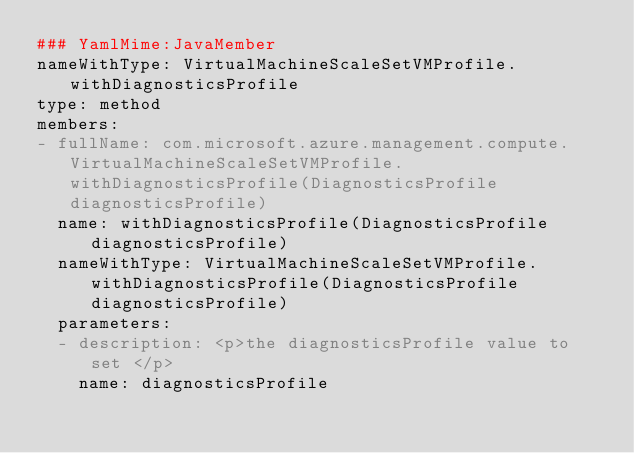Convert code to text. <code><loc_0><loc_0><loc_500><loc_500><_YAML_>### YamlMime:JavaMember
nameWithType: VirtualMachineScaleSetVMProfile.withDiagnosticsProfile
type: method
members:
- fullName: com.microsoft.azure.management.compute.VirtualMachineScaleSetVMProfile.withDiagnosticsProfile(DiagnosticsProfile diagnosticsProfile)
  name: withDiagnosticsProfile(DiagnosticsProfile diagnosticsProfile)
  nameWithType: VirtualMachineScaleSetVMProfile.withDiagnosticsProfile(DiagnosticsProfile diagnosticsProfile)
  parameters:
  - description: <p>the diagnosticsProfile value to set </p>
    name: diagnosticsProfile</code> 